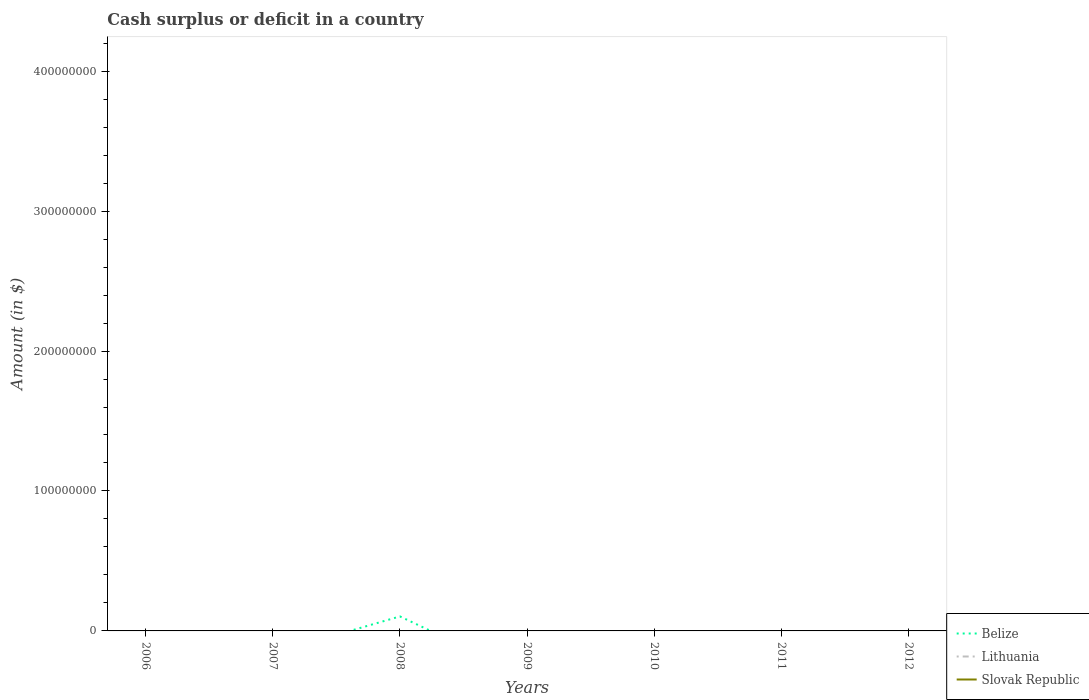How many different coloured lines are there?
Give a very brief answer. 1. Does the line corresponding to Slovak Republic intersect with the line corresponding to Lithuania?
Give a very brief answer. Yes. Is the number of lines equal to the number of legend labels?
Provide a short and direct response. No. Across all years, what is the maximum amount of cash surplus or deficit in Lithuania?
Your answer should be compact. 0. What is the difference between the highest and the second highest amount of cash surplus or deficit in Belize?
Your answer should be compact. 1.04e+07. What is the difference between the highest and the lowest amount of cash surplus or deficit in Lithuania?
Ensure brevity in your answer.  0. Is the amount of cash surplus or deficit in Lithuania strictly greater than the amount of cash surplus or deficit in Belize over the years?
Your answer should be compact. No. What is the difference between two consecutive major ticks on the Y-axis?
Provide a short and direct response. 1.00e+08. Are the values on the major ticks of Y-axis written in scientific E-notation?
Provide a short and direct response. No. Does the graph contain any zero values?
Your response must be concise. Yes. Does the graph contain grids?
Keep it short and to the point. No. Where does the legend appear in the graph?
Keep it short and to the point. Bottom right. How are the legend labels stacked?
Offer a very short reply. Vertical. What is the title of the graph?
Offer a terse response. Cash surplus or deficit in a country. Does "Channel Islands" appear as one of the legend labels in the graph?
Offer a very short reply. No. What is the label or title of the X-axis?
Provide a succinct answer. Years. What is the label or title of the Y-axis?
Keep it short and to the point. Amount (in $). What is the Amount (in $) in Belize in 2006?
Your answer should be very brief. 0. What is the Amount (in $) of Lithuania in 2006?
Your answer should be compact. 0. What is the Amount (in $) in Belize in 2007?
Offer a terse response. 0. What is the Amount (in $) of Belize in 2008?
Offer a very short reply. 1.04e+07. What is the Amount (in $) of Lithuania in 2008?
Give a very brief answer. 0. What is the Amount (in $) of Slovak Republic in 2008?
Ensure brevity in your answer.  0. What is the Amount (in $) of Belize in 2010?
Offer a terse response. 0. What is the Amount (in $) of Lithuania in 2010?
Give a very brief answer. 0. What is the Amount (in $) in Lithuania in 2012?
Your answer should be compact. 0. Across all years, what is the maximum Amount (in $) of Belize?
Provide a succinct answer. 1.04e+07. Across all years, what is the minimum Amount (in $) in Belize?
Give a very brief answer. 0. What is the total Amount (in $) of Belize in the graph?
Provide a succinct answer. 1.04e+07. What is the total Amount (in $) in Lithuania in the graph?
Offer a terse response. 0. What is the total Amount (in $) in Slovak Republic in the graph?
Your answer should be very brief. 0. What is the average Amount (in $) of Belize per year?
Offer a terse response. 1.48e+06. What is the average Amount (in $) of Lithuania per year?
Ensure brevity in your answer.  0. What is the difference between the highest and the lowest Amount (in $) of Belize?
Keep it short and to the point. 1.04e+07. 